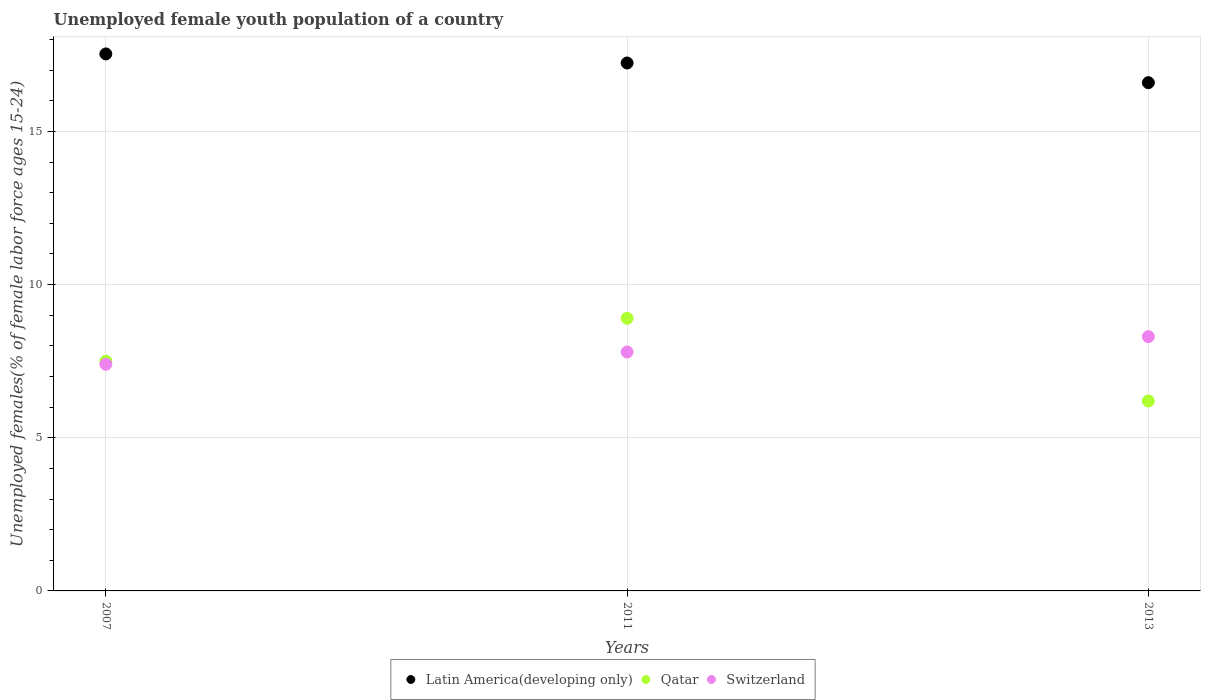How many different coloured dotlines are there?
Your answer should be very brief. 3. What is the percentage of unemployed female youth population in Latin America(developing only) in 2013?
Your answer should be compact. 16.59. Across all years, what is the maximum percentage of unemployed female youth population in Switzerland?
Your response must be concise. 8.3. Across all years, what is the minimum percentage of unemployed female youth population in Latin America(developing only)?
Offer a very short reply. 16.59. In which year was the percentage of unemployed female youth population in Latin America(developing only) maximum?
Keep it short and to the point. 2007. In which year was the percentage of unemployed female youth population in Switzerland minimum?
Your answer should be compact. 2007. What is the total percentage of unemployed female youth population in Qatar in the graph?
Your response must be concise. 22.6. What is the difference between the percentage of unemployed female youth population in Switzerland in 2007 and that in 2011?
Ensure brevity in your answer.  -0.4. What is the difference between the percentage of unemployed female youth population in Switzerland in 2011 and the percentage of unemployed female youth population in Latin America(developing only) in 2013?
Your response must be concise. -8.79. What is the average percentage of unemployed female youth population in Qatar per year?
Your answer should be compact. 7.53. In the year 2011, what is the difference between the percentage of unemployed female youth population in Switzerland and percentage of unemployed female youth population in Qatar?
Make the answer very short. -1.1. What is the ratio of the percentage of unemployed female youth population in Qatar in 2007 to that in 2011?
Keep it short and to the point. 0.84. Is the percentage of unemployed female youth population in Switzerland in 2007 less than that in 2011?
Your answer should be very brief. Yes. What is the difference between the highest and the second highest percentage of unemployed female youth population in Switzerland?
Provide a short and direct response. 0.5. What is the difference between the highest and the lowest percentage of unemployed female youth population in Qatar?
Keep it short and to the point. 2.7. In how many years, is the percentage of unemployed female youth population in Latin America(developing only) greater than the average percentage of unemployed female youth population in Latin America(developing only) taken over all years?
Your answer should be very brief. 2. Is the sum of the percentage of unemployed female youth population in Latin America(developing only) in 2007 and 2013 greater than the maximum percentage of unemployed female youth population in Switzerland across all years?
Your answer should be very brief. Yes. Is it the case that in every year, the sum of the percentage of unemployed female youth population in Qatar and percentage of unemployed female youth population in Switzerland  is greater than the percentage of unemployed female youth population in Latin America(developing only)?
Provide a short and direct response. No. Is the percentage of unemployed female youth population in Switzerland strictly greater than the percentage of unemployed female youth population in Qatar over the years?
Offer a terse response. No. Is the percentage of unemployed female youth population in Switzerland strictly less than the percentage of unemployed female youth population in Latin America(developing only) over the years?
Give a very brief answer. Yes. How many dotlines are there?
Your answer should be compact. 3. Does the graph contain any zero values?
Provide a short and direct response. No. Does the graph contain grids?
Your response must be concise. Yes. How many legend labels are there?
Offer a terse response. 3. What is the title of the graph?
Ensure brevity in your answer.  Unemployed female youth population of a country. What is the label or title of the X-axis?
Ensure brevity in your answer.  Years. What is the label or title of the Y-axis?
Offer a very short reply. Unemployed females(% of female labor force ages 15-24). What is the Unemployed females(% of female labor force ages 15-24) of Latin America(developing only) in 2007?
Keep it short and to the point. 17.53. What is the Unemployed females(% of female labor force ages 15-24) in Qatar in 2007?
Make the answer very short. 7.5. What is the Unemployed females(% of female labor force ages 15-24) in Switzerland in 2007?
Offer a very short reply. 7.4. What is the Unemployed females(% of female labor force ages 15-24) of Latin America(developing only) in 2011?
Make the answer very short. 17.23. What is the Unemployed females(% of female labor force ages 15-24) of Qatar in 2011?
Give a very brief answer. 8.9. What is the Unemployed females(% of female labor force ages 15-24) of Switzerland in 2011?
Provide a succinct answer. 7.8. What is the Unemployed females(% of female labor force ages 15-24) of Latin America(developing only) in 2013?
Give a very brief answer. 16.59. What is the Unemployed females(% of female labor force ages 15-24) of Qatar in 2013?
Provide a short and direct response. 6.2. What is the Unemployed females(% of female labor force ages 15-24) in Switzerland in 2013?
Provide a succinct answer. 8.3. Across all years, what is the maximum Unemployed females(% of female labor force ages 15-24) in Latin America(developing only)?
Your answer should be compact. 17.53. Across all years, what is the maximum Unemployed females(% of female labor force ages 15-24) in Qatar?
Provide a short and direct response. 8.9. Across all years, what is the maximum Unemployed females(% of female labor force ages 15-24) in Switzerland?
Make the answer very short. 8.3. Across all years, what is the minimum Unemployed females(% of female labor force ages 15-24) of Latin America(developing only)?
Ensure brevity in your answer.  16.59. Across all years, what is the minimum Unemployed females(% of female labor force ages 15-24) in Qatar?
Offer a terse response. 6.2. Across all years, what is the minimum Unemployed females(% of female labor force ages 15-24) in Switzerland?
Make the answer very short. 7.4. What is the total Unemployed females(% of female labor force ages 15-24) in Latin America(developing only) in the graph?
Ensure brevity in your answer.  51.36. What is the total Unemployed females(% of female labor force ages 15-24) in Qatar in the graph?
Your answer should be compact. 22.6. What is the difference between the Unemployed females(% of female labor force ages 15-24) in Latin America(developing only) in 2007 and that in 2011?
Your answer should be compact. 0.3. What is the difference between the Unemployed females(% of female labor force ages 15-24) in Qatar in 2007 and that in 2011?
Offer a very short reply. -1.4. What is the difference between the Unemployed females(% of female labor force ages 15-24) of Switzerland in 2007 and that in 2011?
Your answer should be very brief. -0.4. What is the difference between the Unemployed females(% of female labor force ages 15-24) in Latin America(developing only) in 2007 and that in 2013?
Ensure brevity in your answer.  0.94. What is the difference between the Unemployed females(% of female labor force ages 15-24) in Latin America(developing only) in 2011 and that in 2013?
Your answer should be very brief. 0.64. What is the difference between the Unemployed females(% of female labor force ages 15-24) of Qatar in 2011 and that in 2013?
Ensure brevity in your answer.  2.7. What is the difference between the Unemployed females(% of female labor force ages 15-24) in Latin America(developing only) in 2007 and the Unemployed females(% of female labor force ages 15-24) in Qatar in 2011?
Make the answer very short. 8.63. What is the difference between the Unemployed females(% of female labor force ages 15-24) of Latin America(developing only) in 2007 and the Unemployed females(% of female labor force ages 15-24) of Switzerland in 2011?
Your answer should be compact. 9.73. What is the difference between the Unemployed females(% of female labor force ages 15-24) of Qatar in 2007 and the Unemployed females(% of female labor force ages 15-24) of Switzerland in 2011?
Make the answer very short. -0.3. What is the difference between the Unemployed females(% of female labor force ages 15-24) of Latin America(developing only) in 2007 and the Unemployed females(% of female labor force ages 15-24) of Qatar in 2013?
Your response must be concise. 11.33. What is the difference between the Unemployed females(% of female labor force ages 15-24) of Latin America(developing only) in 2007 and the Unemployed females(% of female labor force ages 15-24) of Switzerland in 2013?
Ensure brevity in your answer.  9.23. What is the difference between the Unemployed females(% of female labor force ages 15-24) of Qatar in 2007 and the Unemployed females(% of female labor force ages 15-24) of Switzerland in 2013?
Your answer should be very brief. -0.8. What is the difference between the Unemployed females(% of female labor force ages 15-24) of Latin America(developing only) in 2011 and the Unemployed females(% of female labor force ages 15-24) of Qatar in 2013?
Give a very brief answer. 11.03. What is the difference between the Unemployed females(% of female labor force ages 15-24) in Latin America(developing only) in 2011 and the Unemployed females(% of female labor force ages 15-24) in Switzerland in 2013?
Your answer should be very brief. 8.93. What is the average Unemployed females(% of female labor force ages 15-24) in Latin America(developing only) per year?
Offer a terse response. 17.12. What is the average Unemployed females(% of female labor force ages 15-24) in Qatar per year?
Your answer should be very brief. 7.53. What is the average Unemployed females(% of female labor force ages 15-24) of Switzerland per year?
Ensure brevity in your answer.  7.83. In the year 2007, what is the difference between the Unemployed females(% of female labor force ages 15-24) of Latin America(developing only) and Unemployed females(% of female labor force ages 15-24) of Qatar?
Offer a very short reply. 10.03. In the year 2007, what is the difference between the Unemployed females(% of female labor force ages 15-24) in Latin America(developing only) and Unemployed females(% of female labor force ages 15-24) in Switzerland?
Your answer should be compact. 10.13. In the year 2007, what is the difference between the Unemployed females(% of female labor force ages 15-24) in Qatar and Unemployed females(% of female labor force ages 15-24) in Switzerland?
Give a very brief answer. 0.1. In the year 2011, what is the difference between the Unemployed females(% of female labor force ages 15-24) of Latin America(developing only) and Unemployed females(% of female labor force ages 15-24) of Qatar?
Keep it short and to the point. 8.33. In the year 2011, what is the difference between the Unemployed females(% of female labor force ages 15-24) of Latin America(developing only) and Unemployed females(% of female labor force ages 15-24) of Switzerland?
Give a very brief answer. 9.43. In the year 2011, what is the difference between the Unemployed females(% of female labor force ages 15-24) in Qatar and Unemployed females(% of female labor force ages 15-24) in Switzerland?
Your answer should be very brief. 1.1. In the year 2013, what is the difference between the Unemployed females(% of female labor force ages 15-24) of Latin America(developing only) and Unemployed females(% of female labor force ages 15-24) of Qatar?
Keep it short and to the point. 10.39. In the year 2013, what is the difference between the Unemployed females(% of female labor force ages 15-24) in Latin America(developing only) and Unemployed females(% of female labor force ages 15-24) in Switzerland?
Offer a terse response. 8.29. What is the ratio of the Unemployed females(% of female labor force ages 15-24) in Latin America(developing only) in 2007 to that in 2011?
Your answer should be compact. 1.02. What is the ratio of the Unemployed females(% of female labor force ages 15-24) of Qatar in 2007 to that in 2011?
Keep it short and to the point. 0.84. What is the ratio of the Unemployed females(% of female labor force ages 15-24) in Switzerland in 2007 to that in 2011?
Your answer should be compact. 0.95. What is the ratio of the Unemployed females(% of female labor force ages 15-24) of Latin America(developing only) in 2007 to that in 2013?
Your response must be concise. 1.06. What is the ratio of the Unemployed females(% of female labor force ages 15-24) in Qatar in 2007 to that in 2013?
Give a very brief answer. 1.21. What is the ratio of the Unemployed females(% of female labor force ages 15-24) of Switzerland in 2007 to that in 2013?
Give a very brief answer. 0.89. What is the ratio of the Unemployed females(% of female labor force ages 15-24) of Latin America(developing only) in 2011 to that in 2013?
Provide a short and direct response. 1.04. What is the ratio of the Unemployed females(% of female labor force ages 15-24) in Qatar in 2011 to that in 2013?
Offer a very short reply. 1.44. What is the ratio of the Unemployed females(% of female labor force ages 15-24) in Switzerland in 2011 to that in 2013?
Provide a succinct answer. 0.94. What is the difference between the highest and the second highest Unemployed females(% of female labor force ages 15-24) of Latin America(developing only)?
Your answer should be very brief. 0.3. What is the difference between the highest and the second highest Unemployed females(% of female labor force ages 15-24) of Qatar?
Provide a short and direct response. 1.4. What is the difference between the highest and the second highest Unemployed females(% of female labor force ages 15-24) in Switzerland?
Your answer should be very brief. 0.5. What is the difference between the highest and the lowest Unemployed females(% of female labor force ages 15-24) in Latin America(developing only)?
Make the answer very short. 0.94. 